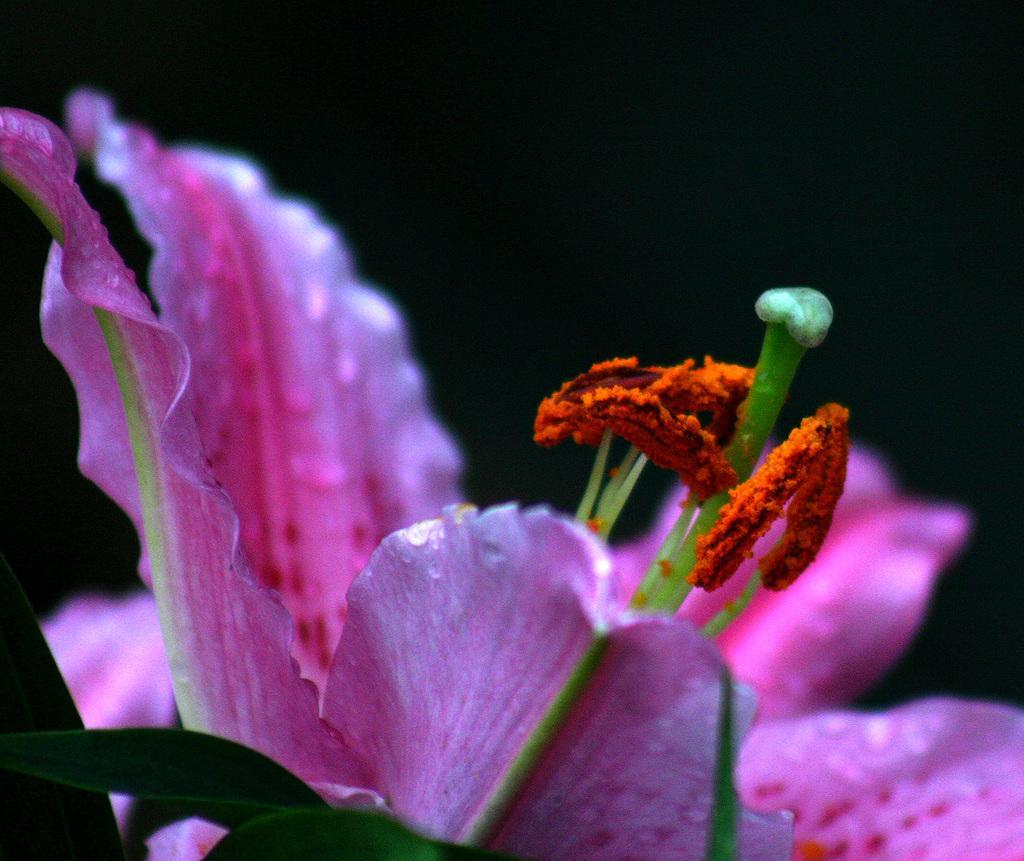Please provide a concise description of this image. There is a beautiful pink flower with two leaves and the background of the flower is dark. 